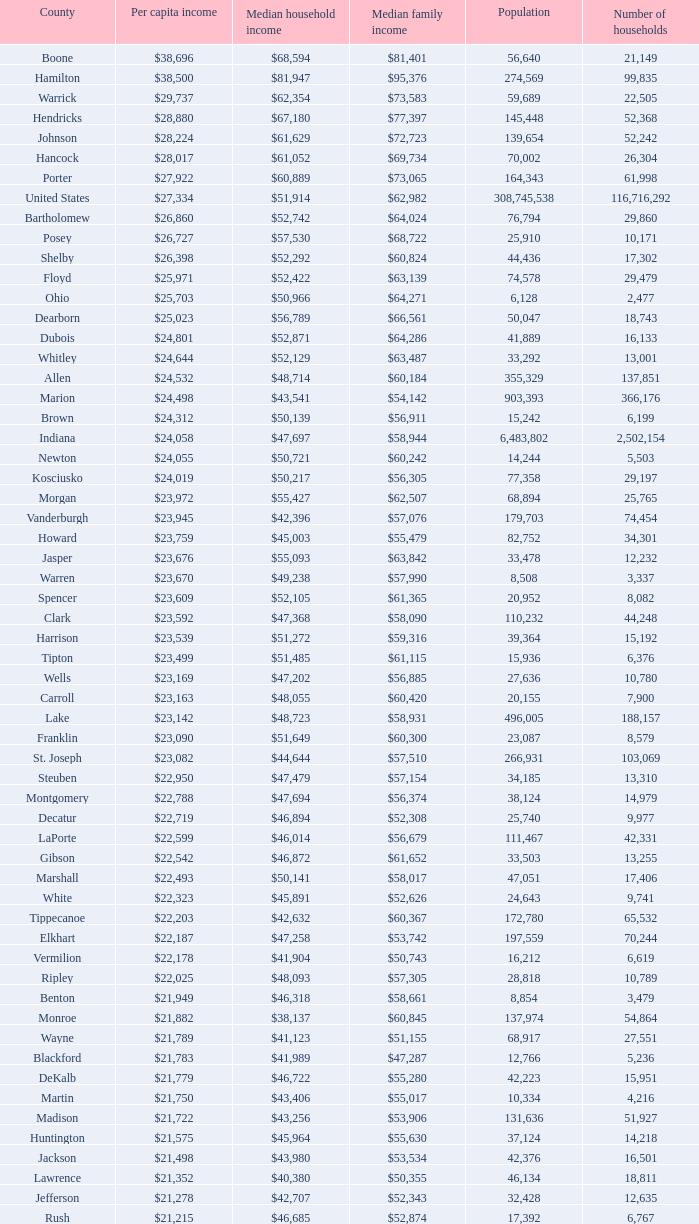Could you parse the entire table? {'header': ['County', 'Per capita income', 'Median household income', 'Median family income', 'Population', 'Number of households'], 'rows': [['Boone', '$38,696', '$68,594', '$81,401', '56,640', '21,149'], ['Hamilton', '$38,500', '$81,947', '$95,376', '274,569', '99,835'], ['Warrick', '$29,737', '$62,354', '$73,583', '59,689', '22,505'], ['Hendricks', '$28,880', '$67,180', '$77,397', '145,448', '52,368'], ['Johnson', '$28,224', '$61,629', '$72,723', '139,654', '52,242'], ['Hancock', '$28,017', '$61,052', '$69,734', '70,002', '26,304'], ['Porter', '$27,922', '$60,889', '$73,065', '164,343', '61,998'], ['United States', '$27,334', '$51,914', '$62,982', '308,745,538', '116,716,292'], ['Bartholomew', '$26,860', '$52,742', '$64,024', '76,794', '29,860'], ['Posey', '$26,727', '$57,530', '$68,722', '25,910', '10,171'], ['Shelby', '$26,398', '$52,292', '$60,824', '44,436', '17,302'], ['Floyd', '$25,971', '$52,422', '$63,139', '74,578', '29,479'], ['Ohio', '$25,703', '$50,966', '$64,271', '6,128', '2,477'], ['Dearborn', '$25,023', '$56,789', '$66,561', '50,047', '18,743'], ['Dubois', '$24,801', '$52,871', '$64,286', '41,889', '16,133'], ['Whitley', '$24,644', '$52,129', '$63,487', '33,292', '13,001'], ['Allen', '$24,532', '$48,714', '$60,184', '355,329', '137,851'], ['Marion', '$24,498', '$43,541', '$54,142', '903,393', '366,176'], ['Brown', '$24,312', '$50,139', '$56,911', '15,242', '6,199'], ['Indiana', '$24,058', '$47,697', '$58,944', '6,483,802', '2,502,154'], ['Newton', '$24,055', '$50,721', '$60,242', '14,244', '5,503'], ['Kosciusko', '$24,019', '$50,217', '$56,305', '77,358', '29,197'], ['Morgan', '$23,972', '$55,427', '$62,507', '68,894', '25,765'], ['Vanderburgh', '$23,945', '$42,396', '$57,076', '179,703', '74,454'], ['Howard', '$23,759', '$45,003', '$55,479', '82,752', '34,301'], ['Jasper', '$23,676', '$55,093', '$63,842', '33,478', '12,232'], ['Warren', '$23,670', '$49,238', '$57,990', '8,508', '3,337'], ['Spencer', '$23,609', '$52,105', '$61,365', '20,952', '8,082'], ['Clark', '$23,592', '$47,368', '$58,090', '110,232', '44,248'], ['Harrison', '$23,539', '$51,272', '$59,316', '39,364', '15,192'], ['Tipton', '$23,499', '$51,485', '$61,115', '15,936', '6,376'], ['Wells', '$23,169', '$47,202', '$56,885', '27,636', '10,780'], ['Carroll', '$23,163', '$48,055', '$60,420', '20,155', '7,900'], ['Lake', '$23,142', '$48,723', '$58,931', '496,005', '188,157'], ['Franklin', '$23,090', '$51,649', '$60,300', '23,087', '8,579'], ['St. Joseph', '$23,082', '$44,644', '$57,510', '266,931', '103,069'], ['Steuben', '$22,950', '$47,479', '$57,154', '34,185', '13,310'], ['Montgomery', '$22,788', '$47,694', '$56,374', '38,124', '14,979'], ['Decatur', '$22,719', '$46,894', '$52,308', '25,740', '9,977'], ['LaPorte', '$22,599', '$46,014', '$56,679', '111,467', '42,331'], ['Gibson', '$22,542', '$46,872', '$61,652', '33,503', '13,255'], ['Marshall', '$22,493', '$50,141', '$58,017', '47,051', '17,406'], ['White', '$22,323', '$45,891', '$52,626', '24,643', '9,741'], ['Tippecanoe', '$22,203', '$42,632', '$60,367', '172,780', '65,532'], ['Elkhart', '$22,187', '$47,258', '$53,742', '197,559', '70,244'], ['Vermilion', '$22,178', '$41,904', '$50,743', '16,212', '6,619'], ['Ripley', '$22,025', '$48,093', '$57,305', '28,818', '10,789'], ['Benton', '$21,949', '$46,318', '$58,661', '8,854', '3,479'], ['Monroe', '$21,882', '$38,137', '$60,845', '137,974', '54,864'], ['Wayne', '$21,789', '$41,123', '$51,155', '68,917', '27,551'], ['Blackford', '$21,783', '$41,989', '$47,287', '12,766', '5,236'], ['DeKalb', '$21,779', '$46,722', '$55,280', '42,223', '15,951'], ['Martin', '$21,750', '$43,406', '$55,017', '10,334', '4,216'], ['Madison', '$21,722', '$43,256', '$53,906', '131,636', '51,927'], ['Huntington', '$21,575', '$45,964', '$55,630', '37,124', '14,218'], ['Jackson', '$21,498', '$43,980', '$53,534', '42,376', '16,501'], ['Lawrence', '$21,352', '$40,380', '$50,355', '46,134', '18,811'], ['Jefferson', '$21,278', '$42,707', '$52,343', '32,428', '12,635'], ['Rush', '$21,215', '$46,685', '$52,874', '17,392', '6,767'], ['Switzerland', '$21,214', '$44,503', '$51,769', '10,613', '4,034'], ['Clinton', '$21,131', '$48,416', '$57,445', '33,224', '12,105'], ['Fulton', '$21,119', '$40,372', '$47,972', '20,836', '8,237'], ['Fountain', '$20,949', '$42,817', '$51,696', '17,240', '6,935'], ['Perry', '$20,806', '$45,108', '$55,497', '19,338', '7,476'], ['Greene', '$20,676', '$41,103', '$50,740', '33,165', '13,487'], ['Owen', '$20,581', '$44,285', '$52,343', '21,575', '8,486'], ['Clay', '$20,569', '$44,666', '$52,907', '26,890', '10,447'], ['Cass', '$20,562', '$42,587', '$49,873', '38,966', '14,858'], ['Pulaski', '$20,491', '$44,016', '$50,903', '13,402', '5,282'], ['Wabash', '$20,475', '$43,157', '$52,758', '32,888', '12,777'], ['Putnam', '$20,441', '$48,992', '$59,354', '37,963', '12,917'], ['Delaware', '$20,405', '$38,066', '$51,394', '117,671', '46,516'], ['Vigo', '$20,398', '$38,508', '$50,413', '107,848', '41,361'], ['Knox', '$20,381', '$39,523', '$51,534', '38,440', '15,249'], ['Daviess', '$20,254', '$44,592', '$53,769', '31,648', '11,329'], ['Sullivan', '$20,093', '$44,184', '$52,558', '21,475', '7,823'], ['Pike', '$20,005', '$41,222', '$49,423', '12,845', '5,186'], ['Henry', '$19,879', '$41,087', '$52,701', '49,462', '19,077'], ['Grant', '$19,792', '$38,985', '$49,860', '70,061', '27,245'], ['Noble', '$19,783', '$45,818', '$53,959', '47,536', '17,355'], ['Randolph', '$19,552', '$40,990', '$45,543', '26,171', '10,451'], ['Parke', '$19,494', '$40,512', '$51,581', '17,339', '6,222'], ['Scott', '$19,414', '$39,588', '$46,775', '24,181', '9,397'], ['Washington', '$19,278', '$39,722', '$45,500', '28,262', '10,850'], ['Union', '$19,243', '$43,257', '$49,815', '7,516', '2,938'], ['Orange', '$19,119', '$37,120', '$45,874', '19,840', '7,872'], ['Adams', '$19,089', '$43,317', '$53,106', '34,387', '12,011'], ['Jay', '$18,946', '$39,886', '$47,926', '21,253', '8,133'], ['Fayette', '$18,928', '$37,038', '$46,601', '24,277', '9,719'], ['Miami', '$18,854', '$39,485', '$49,282', '36,903', '13,456'], ['Jennings', '$18,636', '$43,755', '$48,470', '28,525', '10,680'], ['Crawford', '$18,598', '$37,988', '$46,073', '10,713', '4,303'], ['LaGrange', '$18,388', '$47,792', '$53,793', '37,128', '11,598'], ['Starke', '$17,991', '$37,480', '$44,044', '23,363', '9,038']]} What is the median family revenue when the median household revenue is $38,137? $60,845. 